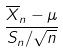Convert formula to latex. <formula><loc_0><loc_0><loc_500><loc_500>\frac { \overline { X } _ { n } - \mu } { S _ { n } / \sqrt { n } }</formula> 